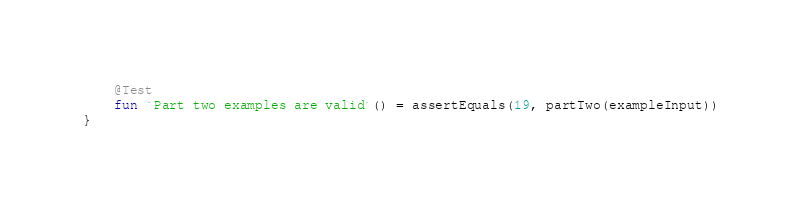Convert code to text. <code><loc_0><loc_0><loc_500><loc_500><_Kotlin_>
    @Test
    fun `Part two examples are valid`() = assertEquals(19, partTwo(exampleInput))
}
</code> 